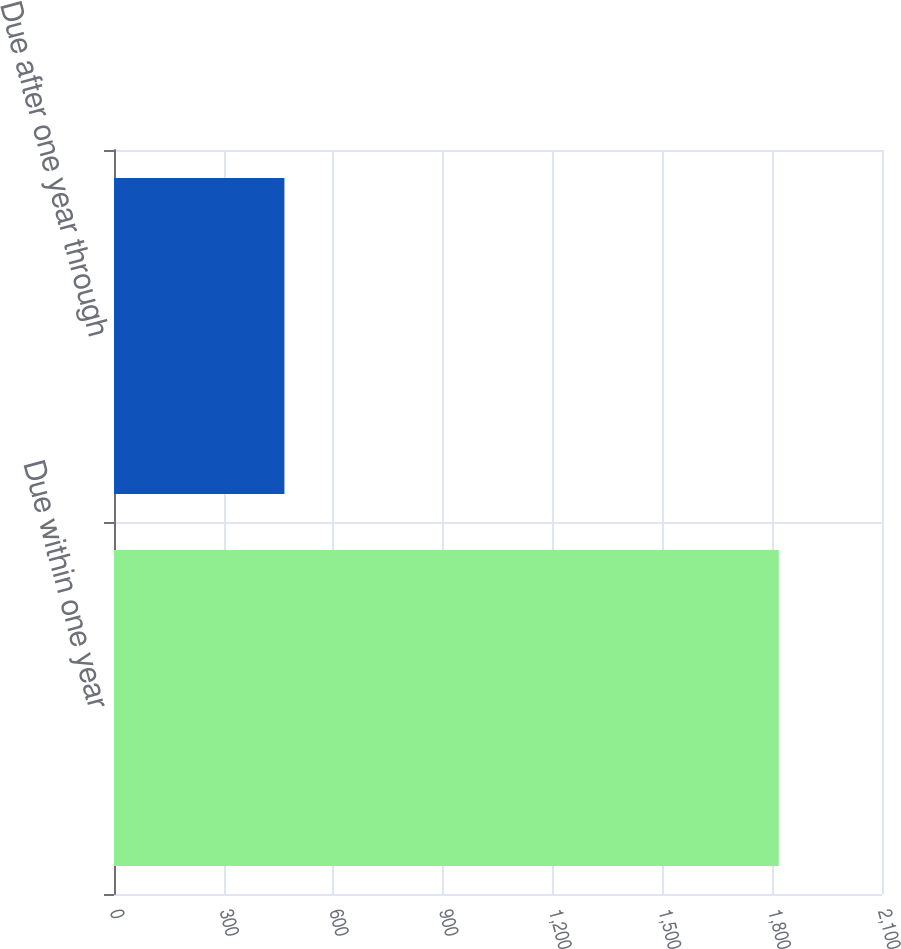Convert chart. <chart><loc_0><loc_0><loc_500><loc_500><bar_chart><fcel>Due within one year<fcel>Due after one year through<nl><fcel>1818<fcel>466<nl></chart> 